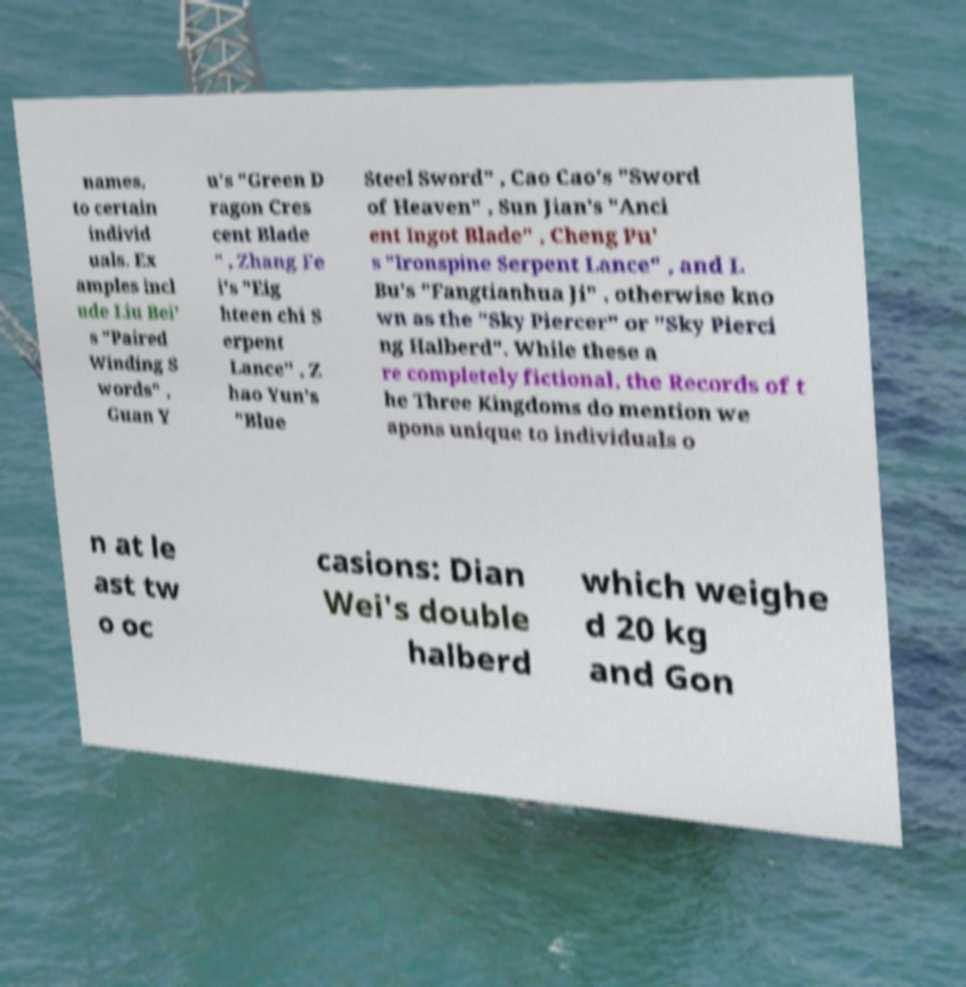Could you assist in decoding the text presented in this image and type it out clearly? names, to certain individ uals. Ex amples incl ude Liu Bei' s "Paired Winding S words" , Guan Y u's "Green D ragon Cres cent Blade " , Zhang Fe i's "Eig hteen chi S erpent Lance" , Z hao Yun's "Blue Steel Sword" , Cao Cao's "Sword of Heaven" , Sun Jian's "Anci ent Ingot Blade" , Cheng Pu' s "Ironspine Serpent Lance" , and L Bu's "Fangtianhua Ji" , otherwise kno wn as the "Sky Piercer" or "Sky Pierci ng Halberd". While these a re completely fictional, the Records of t he Three Kingdoms do mention we apons unique to individuals o n at le ast tw o oc casions: Dian Wei's double halberd which weighe d 20 kg and Gon 